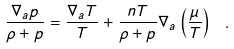Convert formula to latex. <formula><loc_0><loc_0><loc_500><loc_500>\frac { \nabla _ { a } p } { \rho + p } = \frac { \nabla _ { a } T } { T } + \frac { n T } { \rho + p } \nabla _ { a } \left ( \frac { \mu } { T } \right ) \ .</formula> 